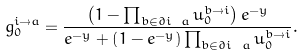Convert formula to latex. <formula><loc_0><loc_0><loc_500><loc_500>g _ { 0 } ^ { i \to a } = \frac { \left ( 1 - \prod _ { b \in \partial i \ a } u _ { 0 } ^ { b \to i } \right ) e ^ { - y } } { e ^ { - y } + \left ( 1 - e ^ { - y } \right ) \prod _ { b \in \partial i \ a } u _ { 0 } ^ { b \to i } } .</formula> 